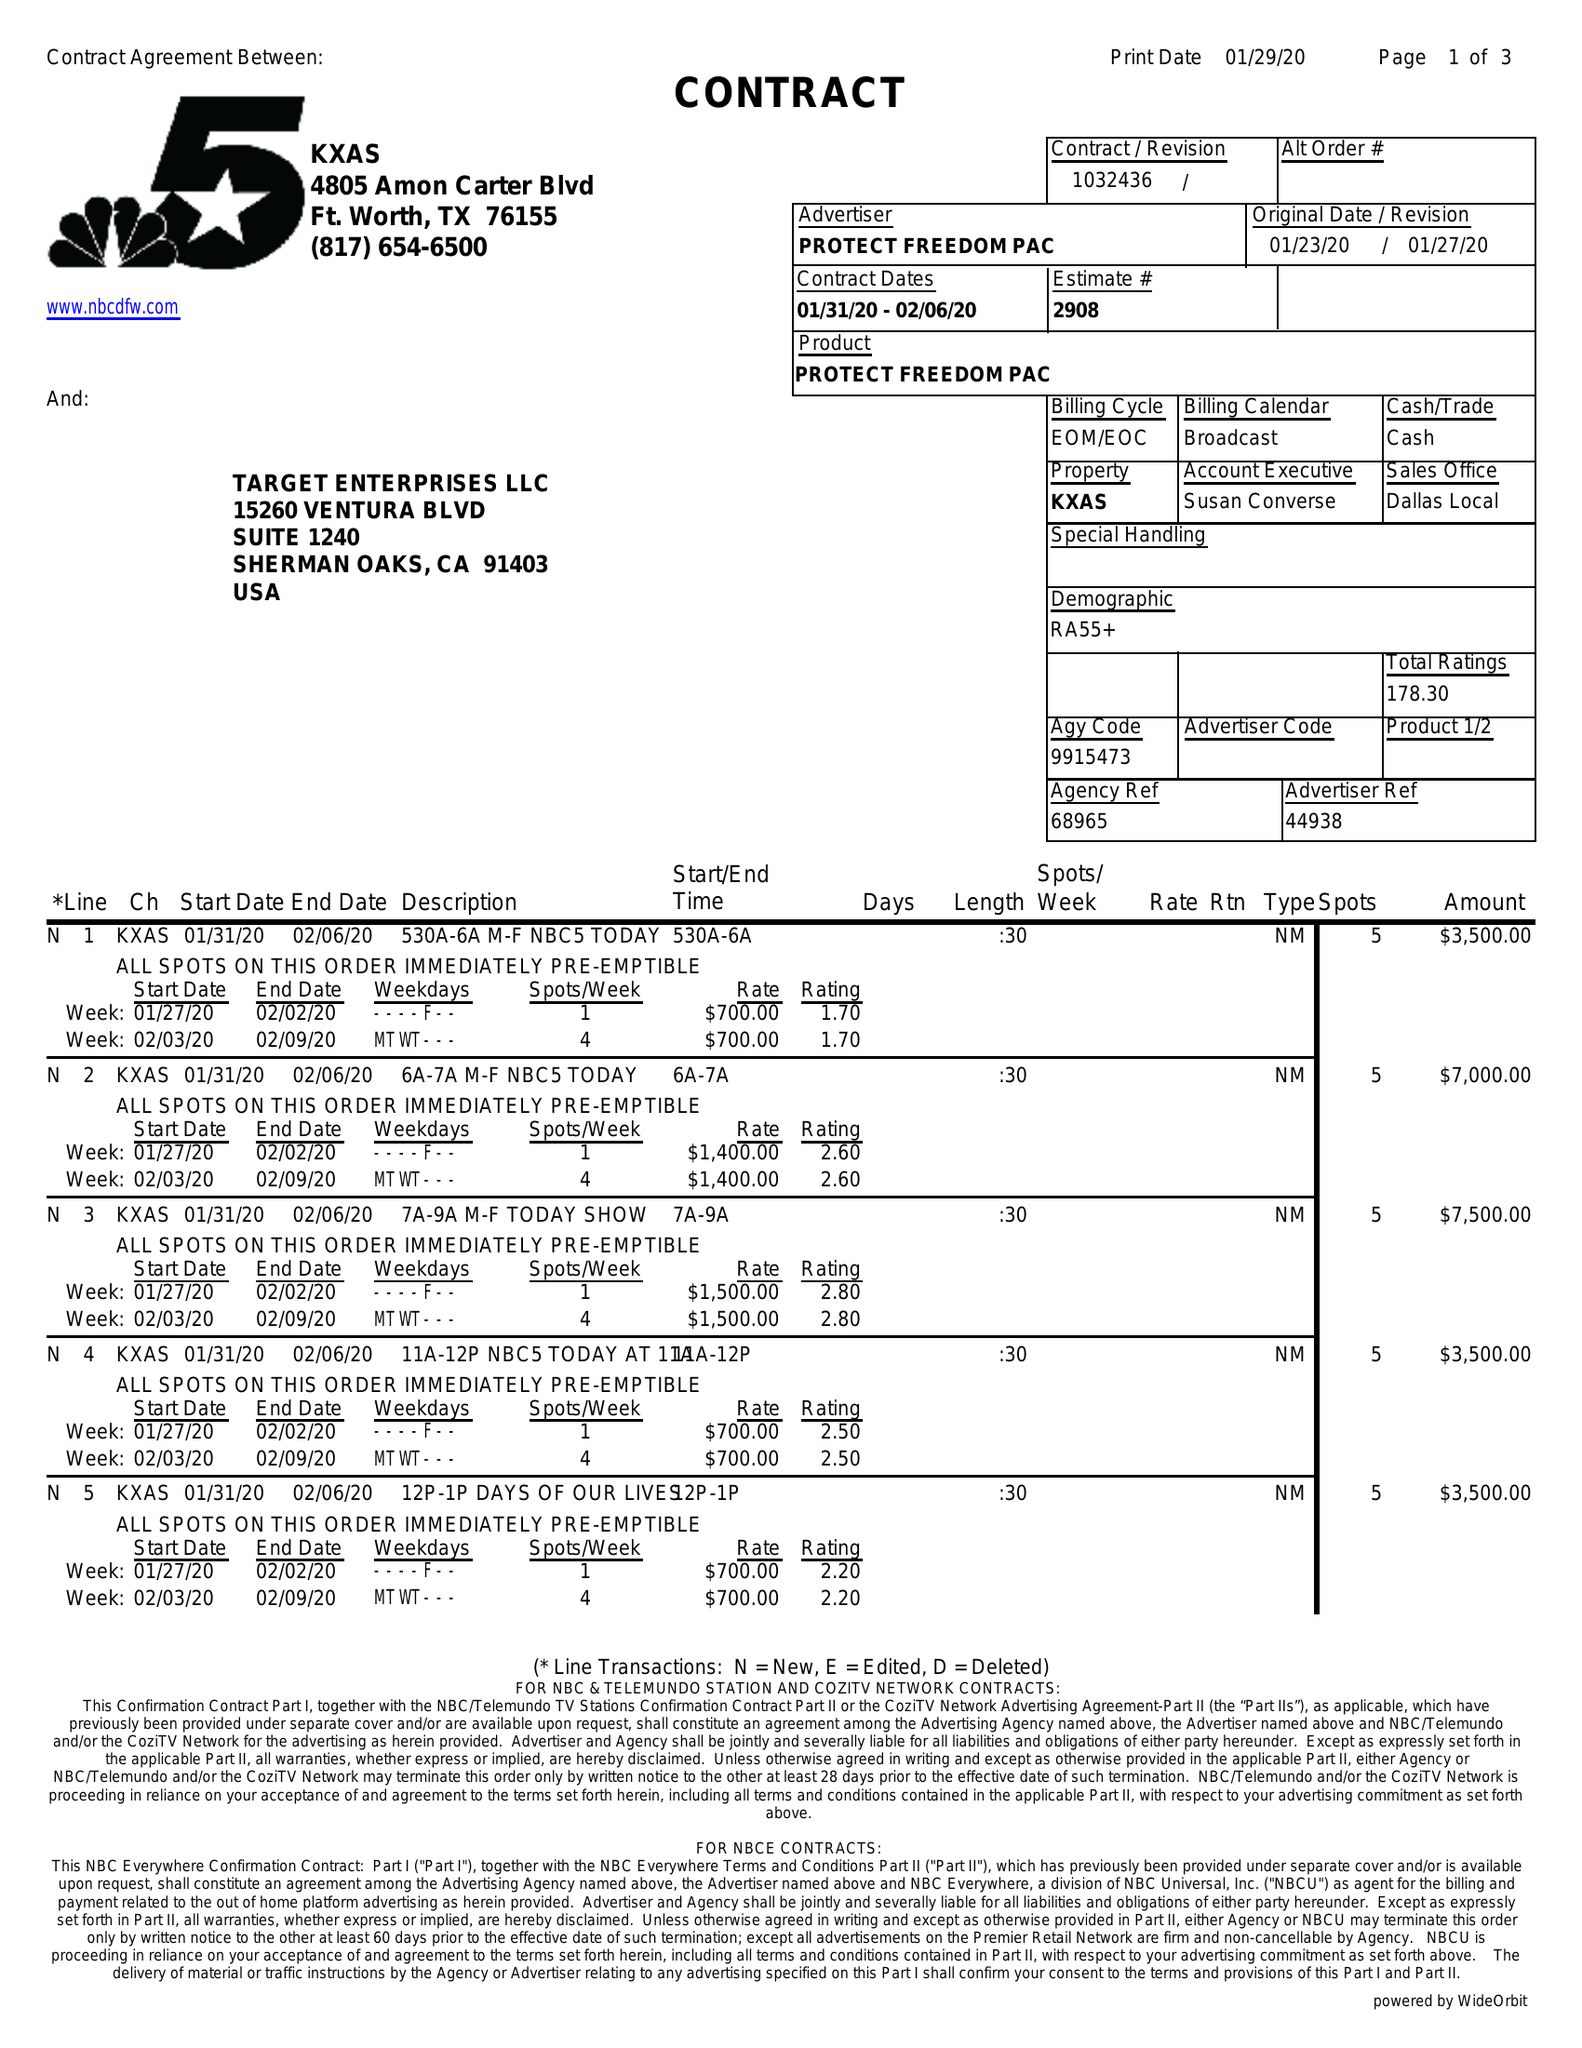What is the value for the advertiser?
Answer the question using a single word or phrase. PROTECT FREEDOM PAC 